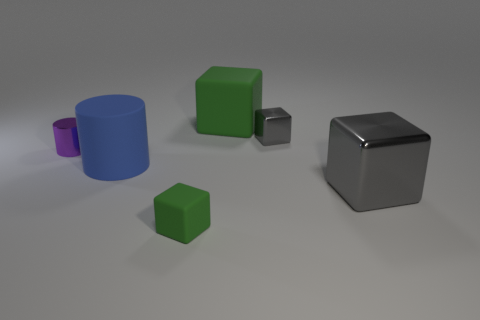The matte object behind the large rubber object that is to the left of the green cube on the right side of the small green matte thing is what shape?
Your answer should be very brief. Cube. What number of objects are large matte cylinders behind the small rubber object or gray shiny cubes behind the large gray metallic thing?
Provide a short and direct response. 2. Are there any purple metal objects in front of the small matte object?
Your answer should be very brief. No. How many objects are gray things that are to the left of the big gray metal object or large rubber things?
Your answer should be compact. 3. How many green things are either metallic blocks or large metal things?
Ensure brevity in your answer.  0. How many other objects are there of the same color as the metal cylinder?
Your answer should be compact. 0. Is the number of tiny green things that are in front of the small green cube less than the number of tiny gray metal objects?
Keep it short and to the point. Yes. There is a tiny object that is to the right of the tiny cube in front of the small shiny object on the right side of the blue cylinder; what is its color?
Offer a very short reply. Gray. There is another gray metallic object that is the same shape as the large shiny thing; what size is it?
Your response must be concise. Small. Are there fewer small gray cubes behind the big green rubber object than cubes that are behind the big blue thing?
Your answer should be very brief. Yes. 